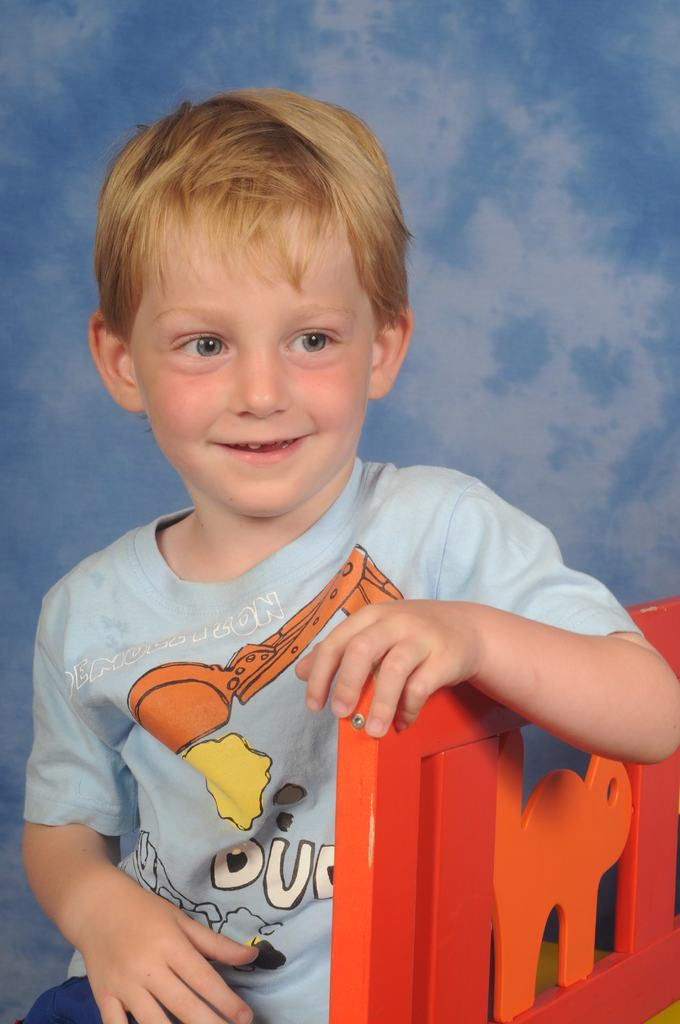Who is the main subject in the image? There is a boy in the image. What is the boy doing in the image? The boy is sitting on a chair. Is the boy holding anything in the image? Yes, the boy is holding the chair. What colors can be seen in the background of the image? The background of the image is white and blue in color. Can you tell me the route the duck takes in the image? There is no duck present in the image, so it is not possible to determine the route it might take. 